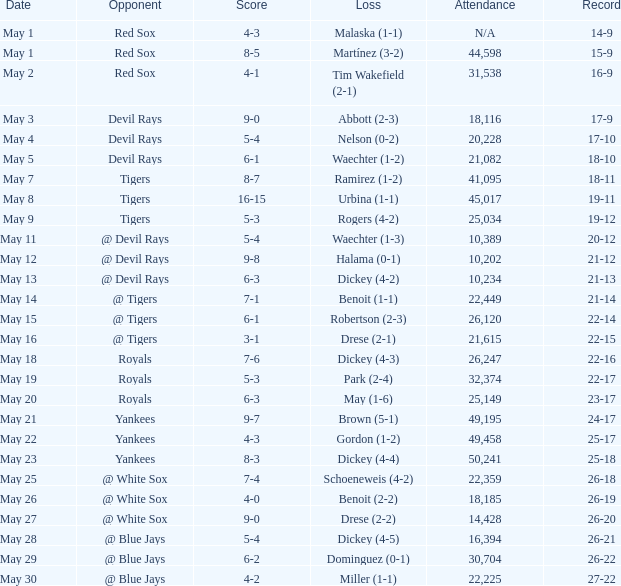What is the score of the game attended by 25,034? 5-3. 